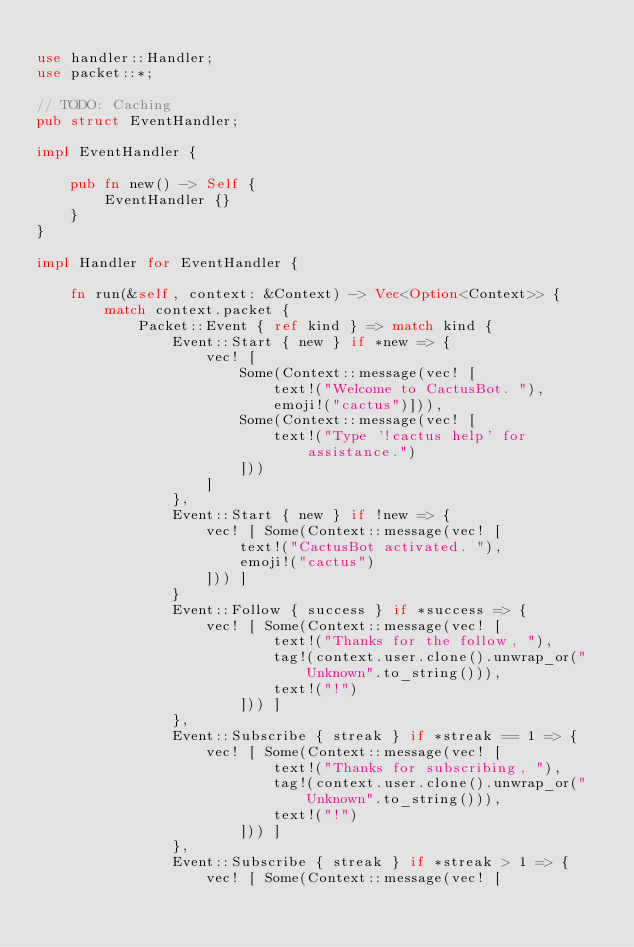Convert code to text. <code><loc_0><loc_0><loc_500><loc_500><_Rust_>
use handler::Handler;
use packet::*;

// TODO: Caching
pub struct EventHandler;

impl EventHandler {

	pub fn new() -> Self {
		EventHandler {}
	}
}

impl Handler for EventHandler {

	fn run(&self, context: &Context) -> Vec<Option<Context>> {
		match context.packet {
			Packet::Event { ref kind } => match kind {
				Event::Start { new } if *new => {
					vec! [
						Some(Context::message(vec! [
							text!("Welcome to CactusBot. "),
							emoji!("cactus")])),
						Some(Context::message(vec! [
							text!("Type '!cactus help' for assistance.")
						]))
					]
				},
				Event::Start { new } if !new => {
					vec! [ Some(Context::message(vec! [
						text!("CactusBot activated. "),
						emoji!("cactus")
					])) ]
				}
				Event::Follow { success } if *success => {
					vec! [ Some(Context::message(vec! [
							text!("Thanks for the follow, "),
							tag!(context.user.clone().unwrap_or("Unknown".to_string())),
							text!("!")
						])) ]
				},
				Event::Subscribe { streak } if *streak == 1 => {
					vec! [ Some(Context::message(vec! [
							text!("Thanks for subscribing, "),
							tag!(context.user.clone().unwrap_or("Unknown".to_string())),
							text!("!")
						])) ]
				},
				Event::Subscribe { streak } if *streak > 1 => {
					vec! [ Some(Context::message(vec! [</code> 